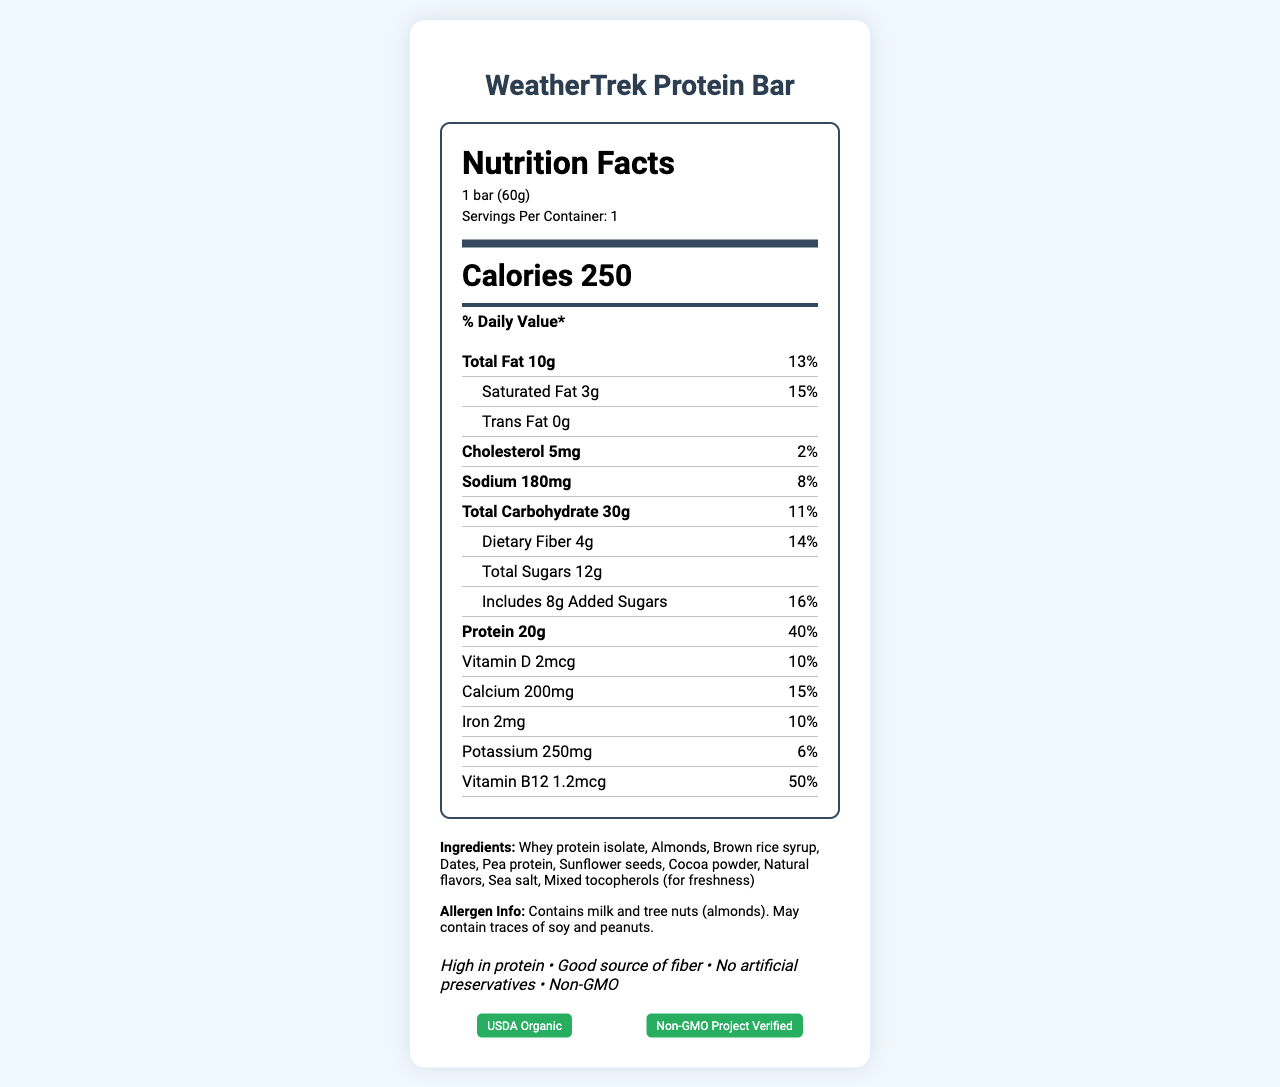What is the serving size of the WeatherTrek Protein Bar? The serving size is listed in the Nutrition Facts section of the label and is specified as "1 bar (60g)."
Answer: 1 bar (60g) How many calories does one WeatherTrek Protein Bar contain? The total number of calories per serving is mentioned right after the serving size and servings per container as "Calories 250."
Answer: 250 What is the total fat content per serving of the WeatherTrek Protein Bar? The total fat content is visible in the nutrient information under "Total Fat 10g."
Answer: 10g How much dietary fiber is in one WeatherTrek Protein Bar? Dietary fiber amount is specified under the Total Carbohydrate section as "Dietary Fiber 4g."
Answer: 4g Which ingredient provides the main protein source for the WeatherTrek Protein Bar? The list of ingredients mentions "Whey protein isolate" first, indicating it's the primary source.
Answer: Whey protein isolate How many servings are in one container of the WeatherTrek Protein Bar? The serving information specifies "Servings Per Container: 1."
Answer: 1 What percentage of daily value for Vitamin B12 does one WeatherTrek Protein Bar provide? The daily value percentage for Vitamin B12 is listed as 50%.
Answer: 50% Which of the following is NOT a claim made about the WeatherTrek Protein Bar? A. High in protein B. Low in sugar C. Good source of fiber The claim statements include "High in protein" and "Good source of fiber," but not "Low in sugar."
Answer: B The WeatherTrek Protein Bar is certified by which organizations? A. USDA Organic B. Non-GMO Project Verified C. Fair Trade Certified The certifications shown include "USDA Organic" and "Non-GMO Project Verified," but not "Fair Trade Certified."
Answer: C Is the WeatherTrek Protein Bar free of artificial preservatives? One of the claim statements explicitly states "No artificial preservatives."
Answer: Yes Summarize the essential features of the WeatherTrek Protein Bar. This summary condenses the primary attributes and nutritional information of the product, describing its purpose, nutritional value, ingredient claims, allergen information, and certifications.
Answer: The WeatherTrek Protein Bar is a high-protein snack designed for field researchers, offering 250 calories per 60g bar. It provides 20g of protein, 10g of fat, 30g of carbohydrates, 4g of dietary fiber, and various vitamins and minerals. The bar is free of artificial preservatives and is non-GMO and USDA Organic certified. It contains milk and tree nuts and might have traces of soy and peanuts. What are the sugars content in the WeatherTrek Protein Bar? The information for total sugars and added sugars is split into two lines, one showing "Total Sugars 12g" and the other "Includes 8g Added Sugars."
Answer: Total Sugars 12g, which includes 8g of added sugars Is the WeatherTrek Protein Bar non-GMO certified? The certifications section includes the label "Non-GMO Project Verified."
Answer: Yes Can you determine the shelf life of the WeatherTrek Protein Bar based on the document? The document advises storing the bar in a cool, dry place and consuming it before the date printed on the package, but the actual shelf life duration is not specified.
Answer: Not enough information 